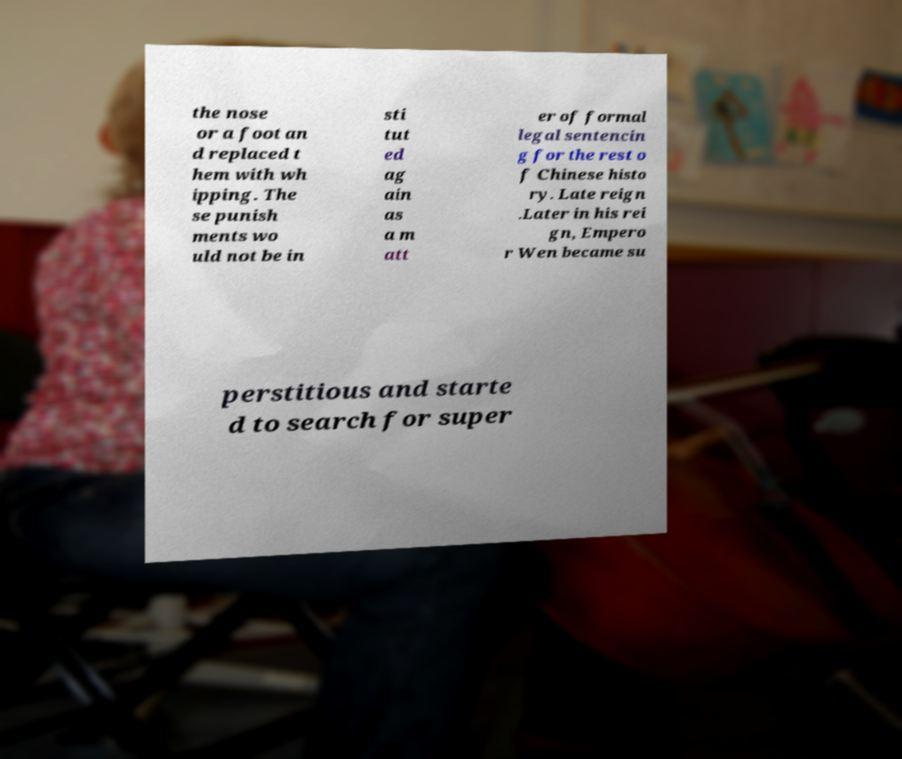Please identify and transcribe the text found in this image. the nose or a foot an d replaced t hem with wh ipping. The se punish ments wo uld not be in sti tut ed ag ain as a m att er of formal legal sentencin g for the rest o f Chinese histo ry. Late reign .Later in his rei gn, Empero r Wen became su perstitious and starte d to search for super 